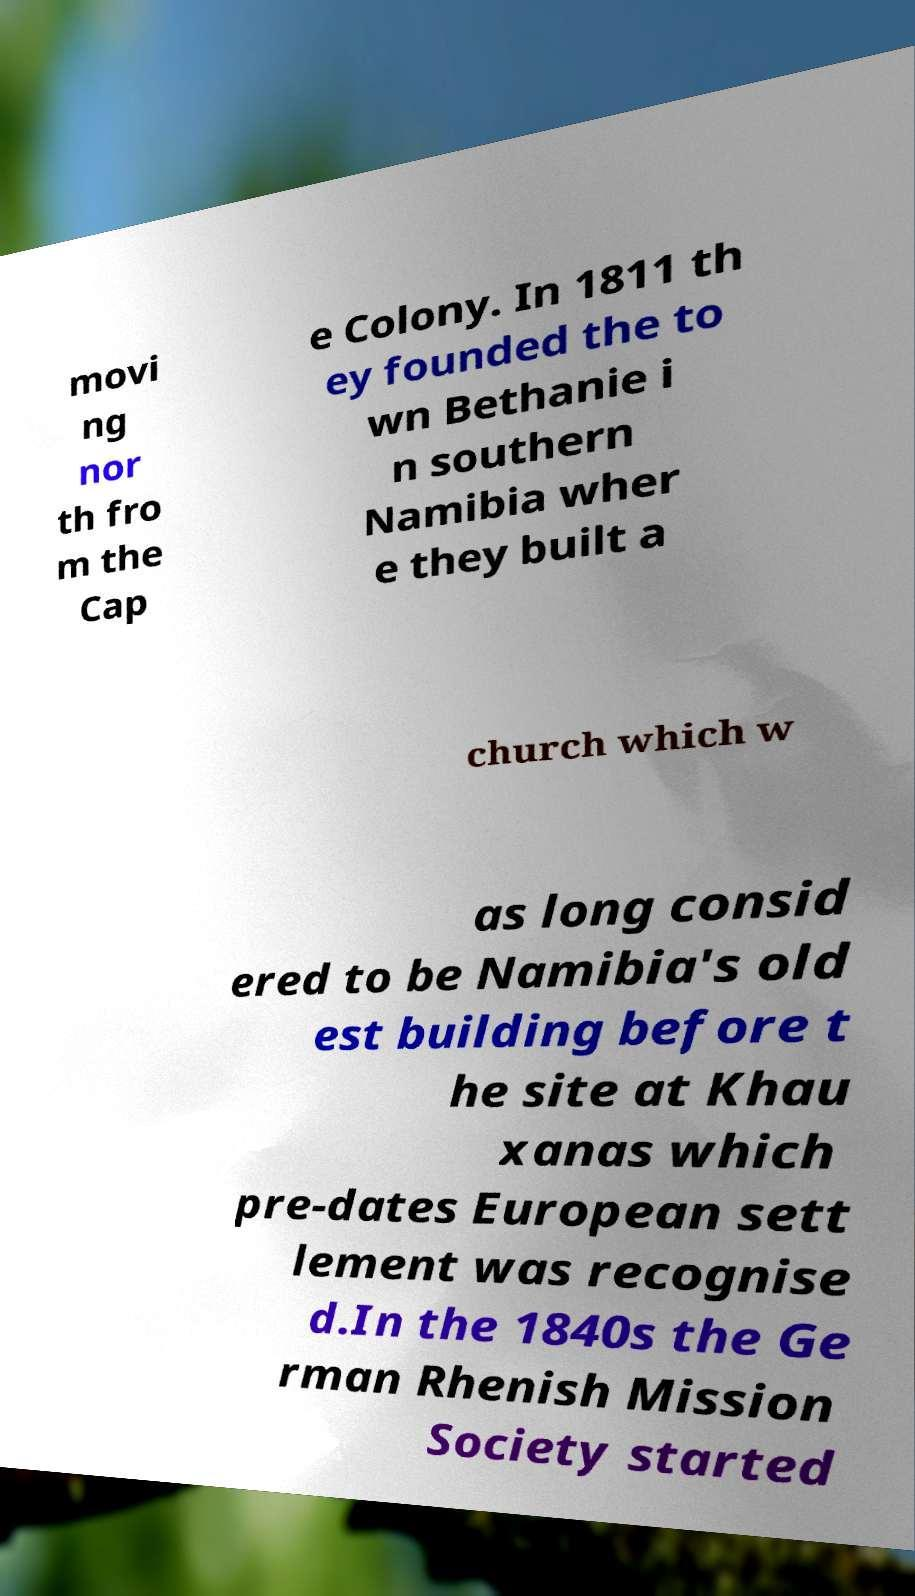Please identify and transcribe the text found in this image. movi ng nor th fro m the Cap e Colony. In 1811 th ey founded the to wn Bethanie i n southern Namibia wher e they built a church which w as long consid ered to be Namibia's old est building before t he site at Khau xanas which pre-dates European sett lement was recognise d.In the 1840s the Ge rman Rhenish Mission Society started 